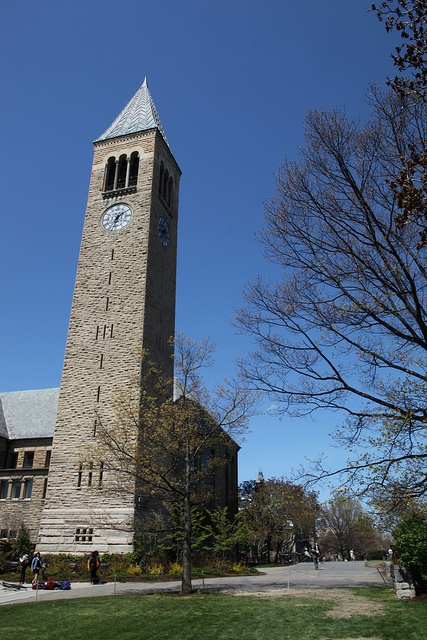Describe the objects in this image and their specific colors. I can see clock in blue, lightgray, darkgray, and lightblue tones, people in blue, black, gray, and darkgray tones, people in blue, black, maroon, and olive tones, people in blue, black, gray, maroon, and lightgray tones, and people in blue, black, gray, and darkgray tones in this image. 